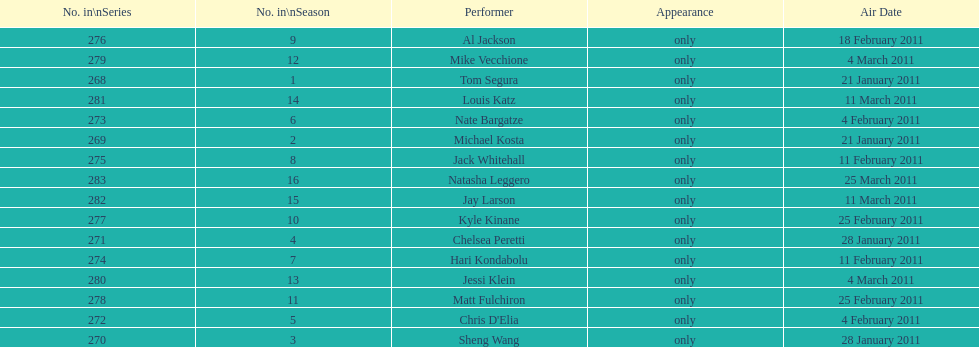How many episodes only had one performer? 16. 